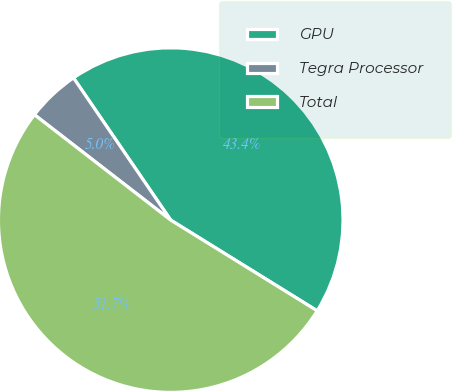Convert chart. <chart><loc_0><loc_0><loc_500><loc_500><pie_chart><fcel>GPU<fcel>Tegra Processor<fcel>Total<nl><fcel>43.37%<fcel>4.98%<fcel>51.65%<nl></chart> 